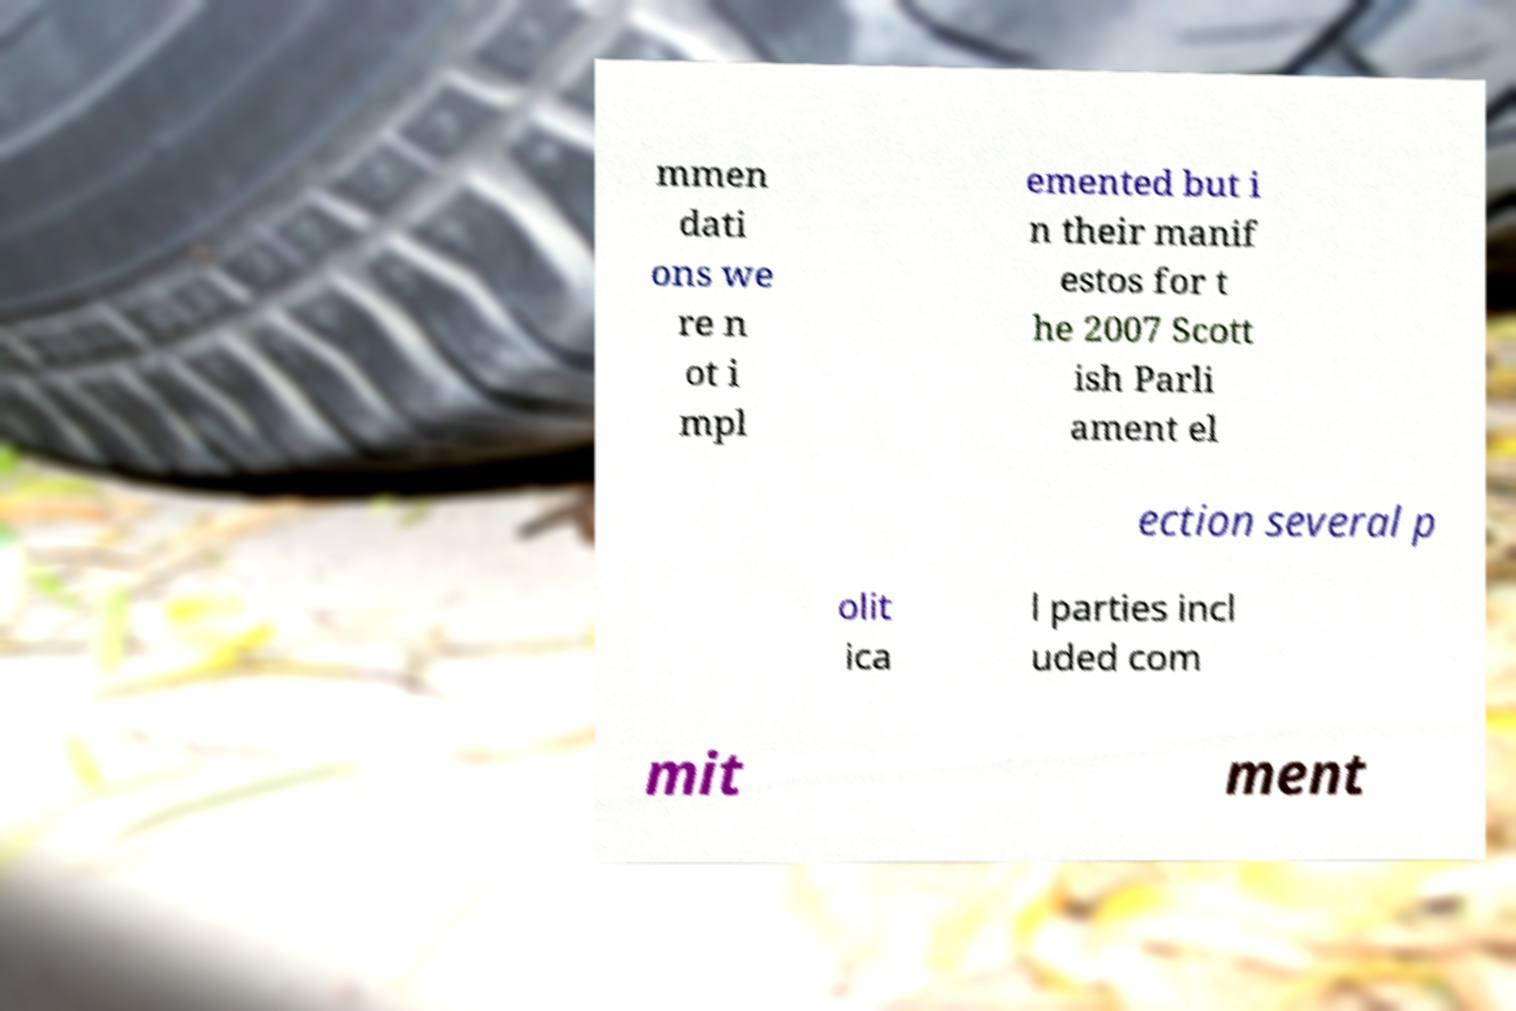Can you read and provide the text displayed in the image?This photo seems to have some interesting text. Can you extract and type it out for me? mmen dati ons we re n ot i mpl emented but i n their manif estos for t he 2007 Scott ish Parli ament el ection several p olit ica l parties incl uded com mit ment 